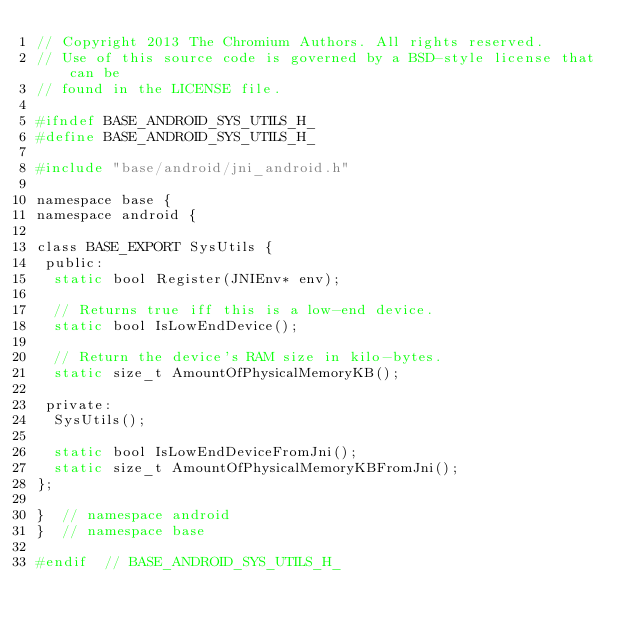Convert code to text. <code><loc_0><loc_0><loc_500><loc_500><_C_>// Copyright 2013 The Chromium Authors. All rights reserved.
// Use of this source code is governed by a BSD-style license that can be
// found in the LICENSE file.

#ifndef BASE_ANDROID_SYS_UTILS_H_
#define BASE_ANDROID_SYS_UTILS_H_

#include "base/android/jni_android.h"

namespace base {
namespace android {

class BASE_EXPORT SysUtils {
 public:
  static bool Register(JNIEnv* env);

  // Returns true iff this is a low-end device.
  static bool IsLowEndDevice();

  // Return the device's RAM size in kilo-bytes.
  static size_t AmountOfPhysicalMemoryKB();

 private:
  SysUtils();

  static bool IsLowEndDeviceFromJni();
  static size_t AmountOfPhysicalMemoryKBFromJni();
};

}  // namespace android
}  // namespace base

#endif  // BASE_ANDROID_SYS_UTILS_H_
</code> 